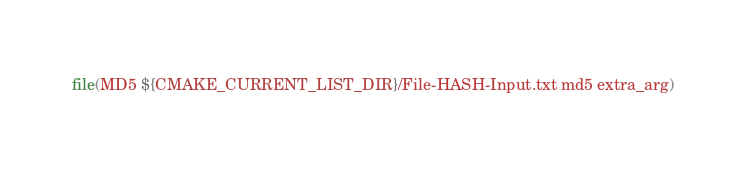Convert code to text. <code><loc_0><loc_0><loc_500><loc_500><_CMake_>file(MD5 ${CMAKE_CURRENT_LIST_DIR}/File-HASH-Input.txt md5 extra_arg)
</code> 